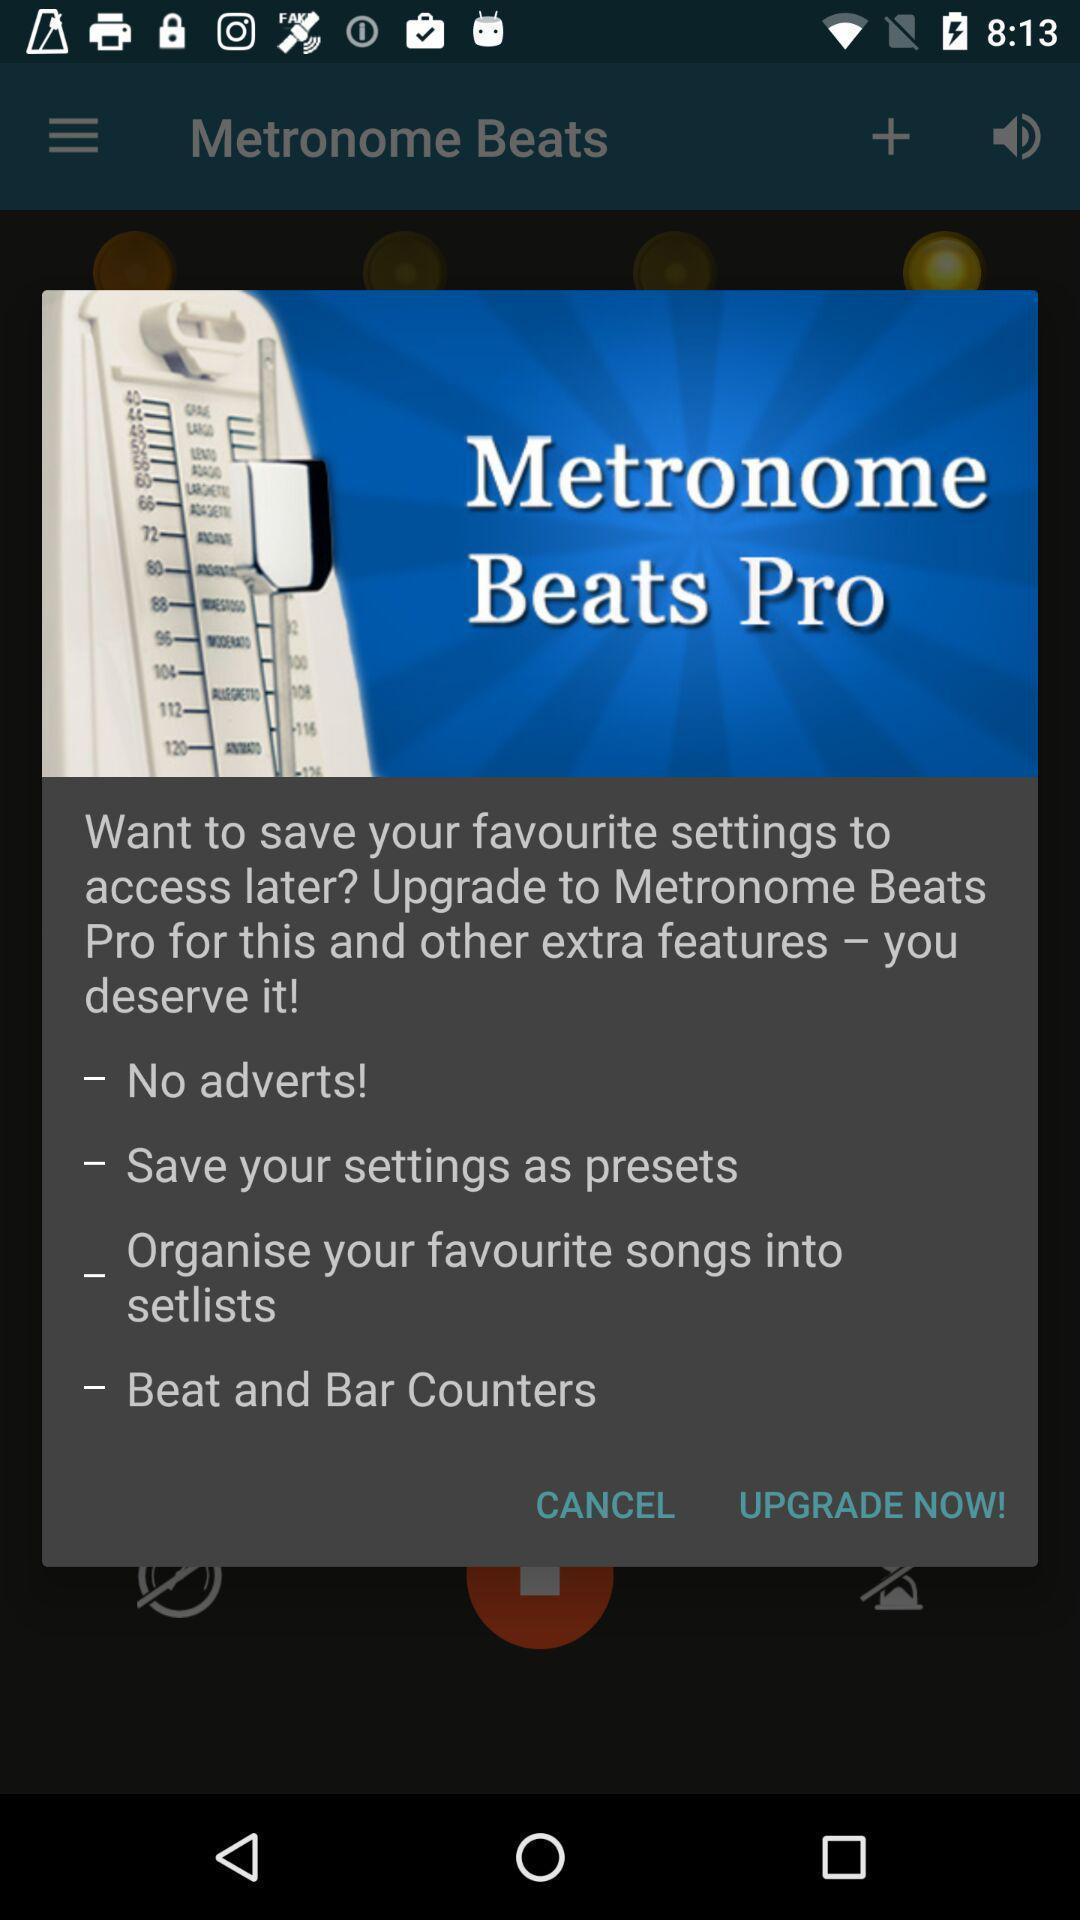Summarize the main components in this picture. Pop-up shows upgrade details of a music app. 